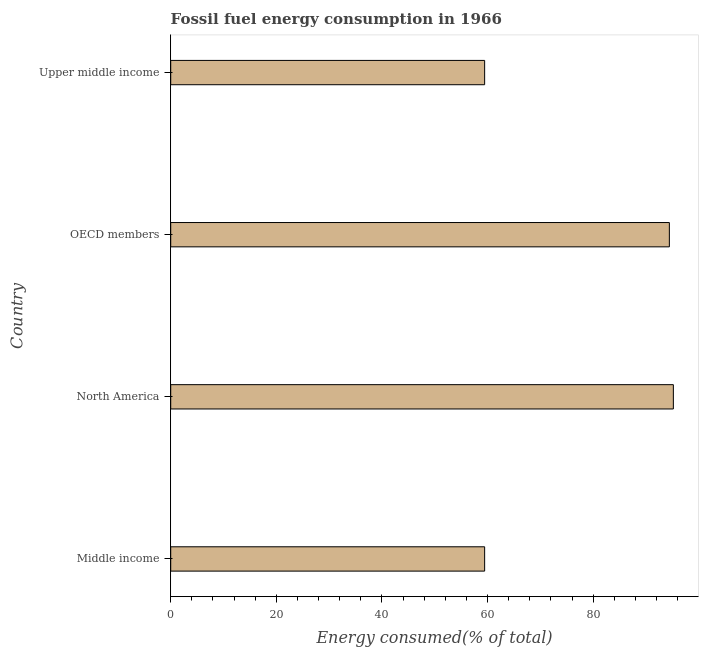What is the title of the graph?
Your response must be concise. Fossil fuel energy consumption in 1966. What is the label or title of the X-axis?
Offer a very short reply. Energy consumed(% of total). What is the fossil fuel energy consumption in Upper middle income?
Provide a succinct answer. 59.45. Across all countries, what is the maximum fossil fuel energy consumption?
Your answer should be very brief. 95.19. Across all countries, what is the minimum fossil fuel energy consumption?
Provide a succinct answer. 59.45. In which country was the fossil fuel energy consumption maximum?
Your response must be concise. North America. What is the sum of the fossil fuel energy consumption?
Give a very brief answer. 308.52. What is the difference between the fossil fuel energy consumption in North America and Upper middle income?
Offer a very short reply. 35.74. What is the average fossil fuel energy consumption per country?
Provide a succinct answer. 77.13. What is the median fossil fuel energy consumption?
Your response must be concise. 76.94. What is the ratio of the fossil fuel energy consumption in Middle income to that in Upper middle income?
Provide a short and direct response. 1. Is the difference between the fossil fuel energy consumption in North America and OECD members greater than the difference between any two countries?
Offer a terse response. No. What is the difference between the highest and the second highest fossil fuel energy consumption?
Offer a terse response. 0.76. Is the sum of the fossil fuel energy consumption in North America and OECD members greater than the maximum fossil fuel energy consumption across all countries?
Your answer should be very brief. Yes. What is the difference between the highest and the lowest fossil fuel energy consumption?
Your answer should be compact. 35.74. How many bars are there?
Offer a terse response. 4. Are all the bars in the graph horizontal?
Keep it short and to the point. Yes. How many countries are there in the graph?
Ensure brevity in your answer.  4. What is the difference between two consecutive major ticks on the X-axis?
Your response must be concise. 20. What is the Energy consumed(% of total) in Middle income?
Provide a short and direct response. 59.45. What is the Energy consumed(% of total) of North America?
Ensure brevity in your answer.  95.19. What is the Energy consumed(% of total) of OECD members?
Provide a short and direct response. 94.43. What is the Energy consumed(% of total) of Upper middle income?
Your answer should be very brief. 59.45. What is the difference between the Energy consumed(% of total) in Middle income and North America?
Provide a succinct answer. -35.74. What is the difference between the Energy consumed(% of total) in Middle income and OECD members?
Ensure brevity in your answer.  -34.98. What is the difference between the Energy consumed(% of total) in Middle income and Upper middle income?
Keep it short and to the point. 0. What is the difference between the Energy consumed(% of total) in North America and OECD members?
Make the answer very short. 0.76. What is the difference between the Energy consumed(% of total) in North America and Upper middle income?
Give a very brief answer. 35.74. What is the difference between the Energy consumed(% of total) in OECD members and Upper middle income?
Provide a succinct answer. 34.98. What is the ratio of the Energy consumed(% of total) in Middle income to that in OECD members?
Provide a short and direct response. 0.63. What is the ratio of the Energy consumed(% of total) in North America to that in Upper middle income?
Make the answer very short. 1.6. What is the ratio of the Energy consumed(% of total) in OECD members to that in Upper middle income?
Provide a short and direct response. 1.59. 